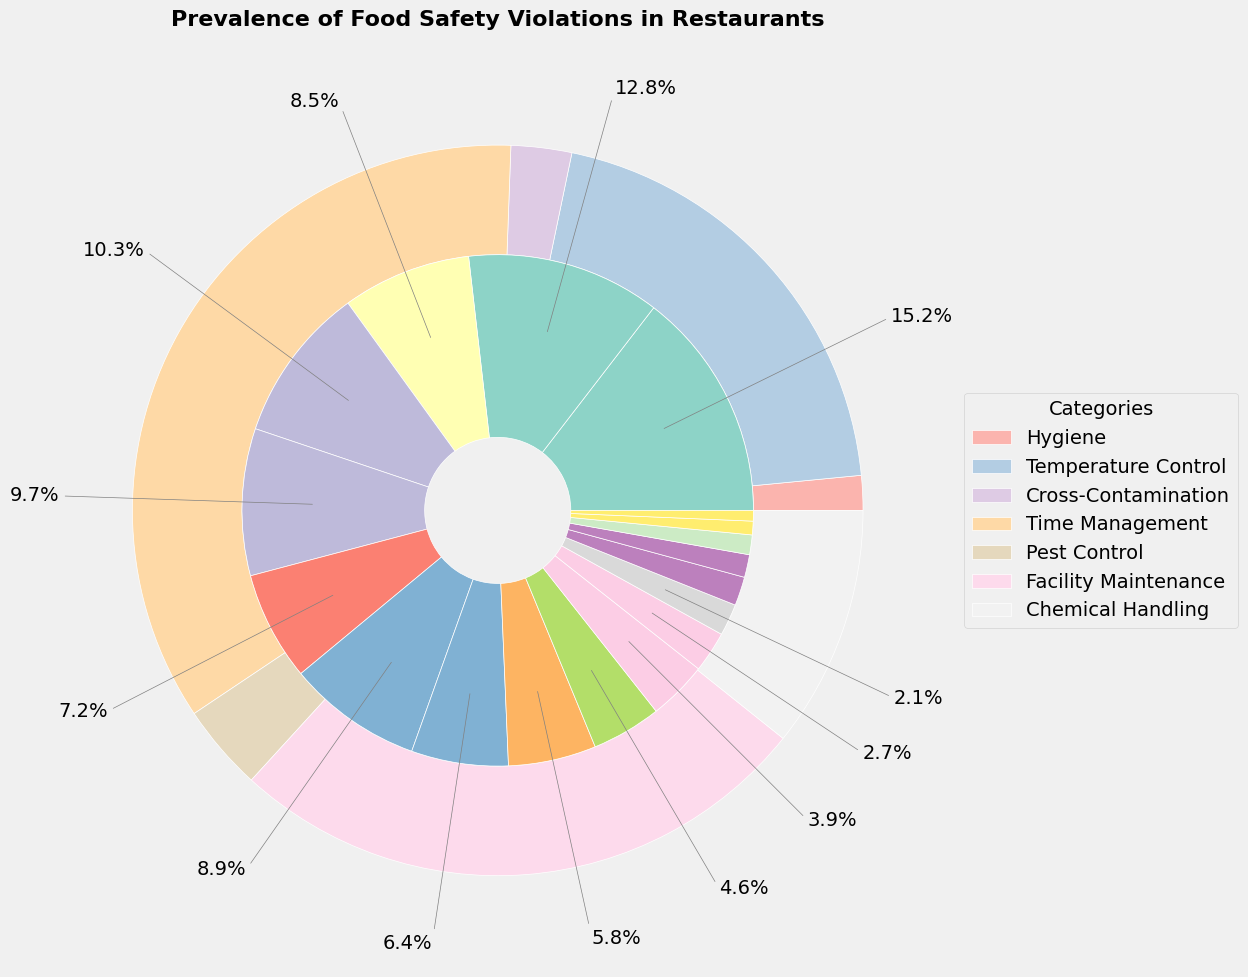Which category has the highest prevalence of food safety violations? To determine which category has the highest prevalence, look at the outer pie chart and compare the sizes of the slices. The largest slice represents Hygiene.
Answer: Hygiene What percentage of total violations are related to Temperature Control? Sum the percentages of the subcategories under Temperature Control: 10.3% (Inadequate hot holding temperatures) + 9.7% (Improper cold holding temperatures) + 7.2% (Improper cooking temperatures) = 27.2%.
Answer: 27.2% How does the prevalence of Hand washing violations compare to Evidence of rodents? Look at the sizes of the segments for Hand washing violations and Evidence of rodents in the inner pie chart. Hand washing violations are 15.2%, whereas Evidence of rodents is 2.1%. Hand washing violations are significantly higher.
Answer: Hand washing violations are higher Which subcategory within Cross-Contamination has the highest percentage? Compare the segments within the Cross-Contamination category in the inner pie chart. The subcategory with the highest percentage is Improper food storage at 8.9%.
Answer: Improper food storage What is the combined percentage of violations related to Pest Control? Sum the percentages of the subcategories under Pest Control: 2.1% (Evidence of rodents) + 1.9% (Evidence of insects) = 4.0%.
Answer: 4.0% Which category has the least prevalence of food safety violations, and what is the percentage? Compare the sizes of the slices in the outer pie chart. The smallest slice represents Chemical Handling. Sum the percentages of the subcategories under Chemical Handling: 0.9% (Improper storage of cleaning chemicals) + 0.7% (Incorrect use of sanitizers). The combined percentage is 1.6%.
Answer: Chemical Handling, 1.6% Are improper cleaning of equipment violations more prevalent than improper cold holding temperatures violations? Compare the sizes of the segments for Improper cleaning of equipment and Improper cold holding temperatures. Improper cleaning of equipment is 12.8%, while Improper cold holding temperatures are 9.7%. Improper cleaning of equipment violations are more prevalent.
Answer: Yes What percentage of violations are related to Time Management? Sum the percentages of the subcategories under Time Management: 4.6% (Food not discarded after expiration) + 3.9% (Inadequate cooling procedures) + 2.7% (Improper thawing methods) = 11.2%.
Answer: 11.2% Which subcategory under Hygiene has the lowest percentage of violations? Compare the segments within the Hygiene category in the inner pie chart. The subcategory with the lowest percentage is Personal hygiene issues at 8.5%.
Answer: Personal hygiene issues Is the prevalence of Personal hygiene issues higher or lower than Plumbing issues? Look at the segments for Personal hygiene issues and Plumbing issues. Personal hygiene issues are 8.5%, whereas Plumbing issues are 1.5%. Personal hygiene issues are higher.
Answer: Higher 